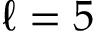Convert formula to latex. <formula><loc_0><loc_0><loc_500><loc_500>\ell = 5</formula> 